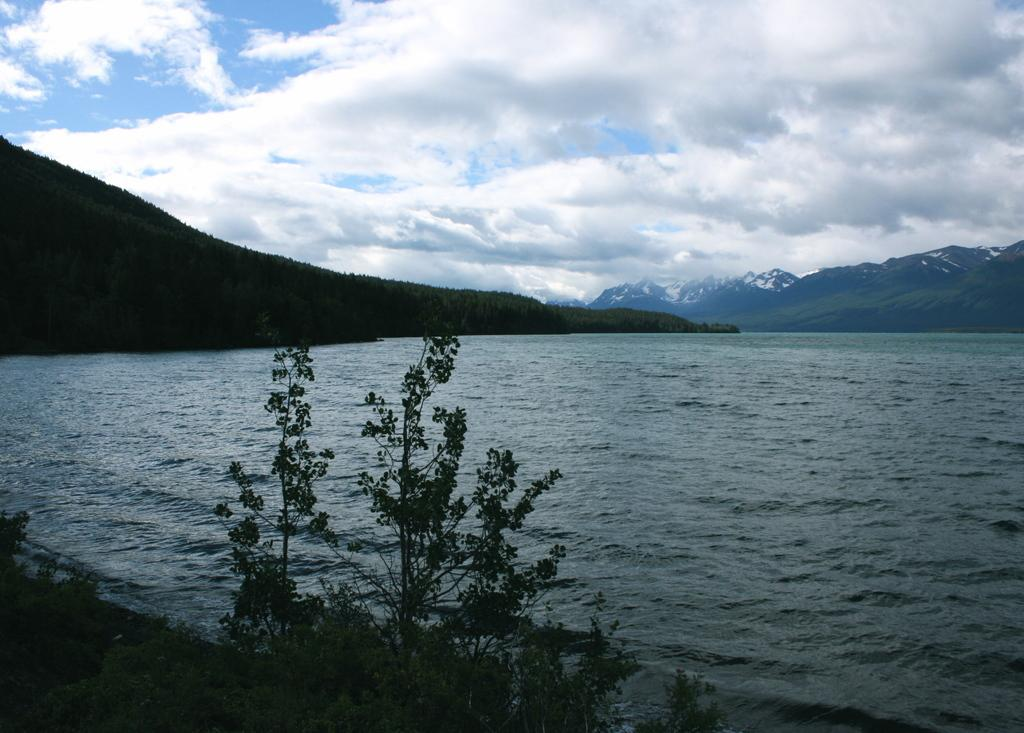What is the main element in the image? There is water in the image. What is located in front of the water? There are plants in front of the water. What can be seen in the background of the image? There are mountains visible behind the water. What is visible at the top of the image? The sky is clear and visible at the top of the image. How many cracks are visible on the cent in the image? There is no cent present in the image, so it is not possible to determine the number of cracks. 